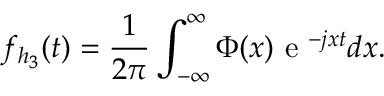Convert formula to latex. <formula><loc_0><loc_0><loc_500><loc_500>f _ { { h _ { 3 } } } ( t ) = \frac { 1 } { 2 \pi } \int _ { - \infty } ^ { \infty } \Phi ( x ) e ^ { - j x t } d x .</formula> 